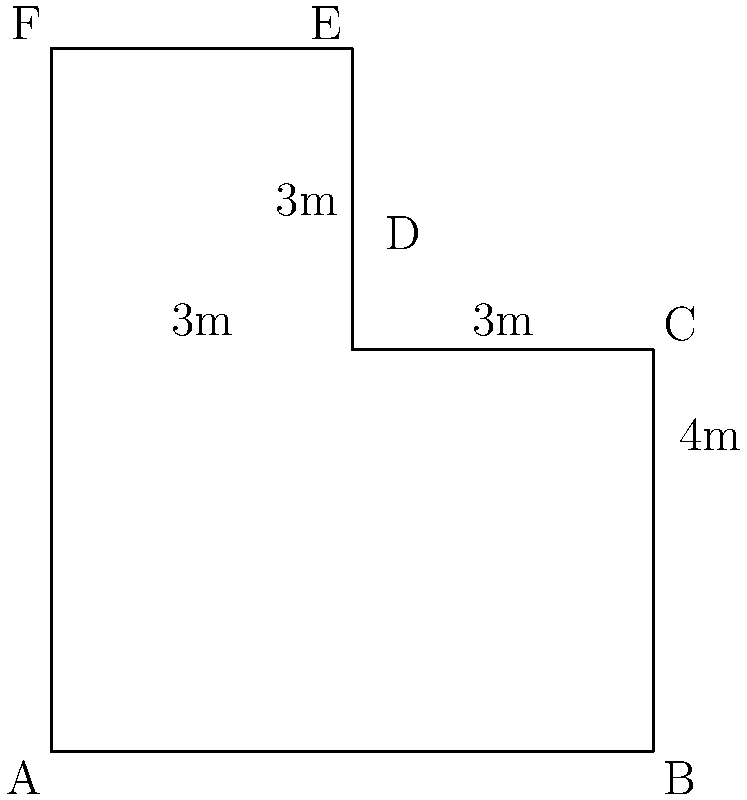You're designing a new indoor space for your animal rescue shelter. The space is L-shaped, composed of two rectangles as shown in the diagram. If the dimensions are as indicated (in meters), what is the total area of this indoor shelter space? To find the total area of the L-shaped space, we need to calculate the areas of the two rectangles separately and then add them together.

1. Area of the larger rectangle (ABCF):
   Length = 6m, Width = 4m
   Area_1 = $6 \times 4 = 24$ sq meters

2. Area of the smaller rectangle (DECF):
   Length = 3m, Width = 3m
   Area_2 = $3 \times 3 = 9$ sq meters

3. Total area:
   Total Area = Area_1 + Area_2
               = $24 + 9 = 33$ sq meters

Therefore, the total area of the indoor shelter space is 33 square meters.
Answer: 33 sq meters 